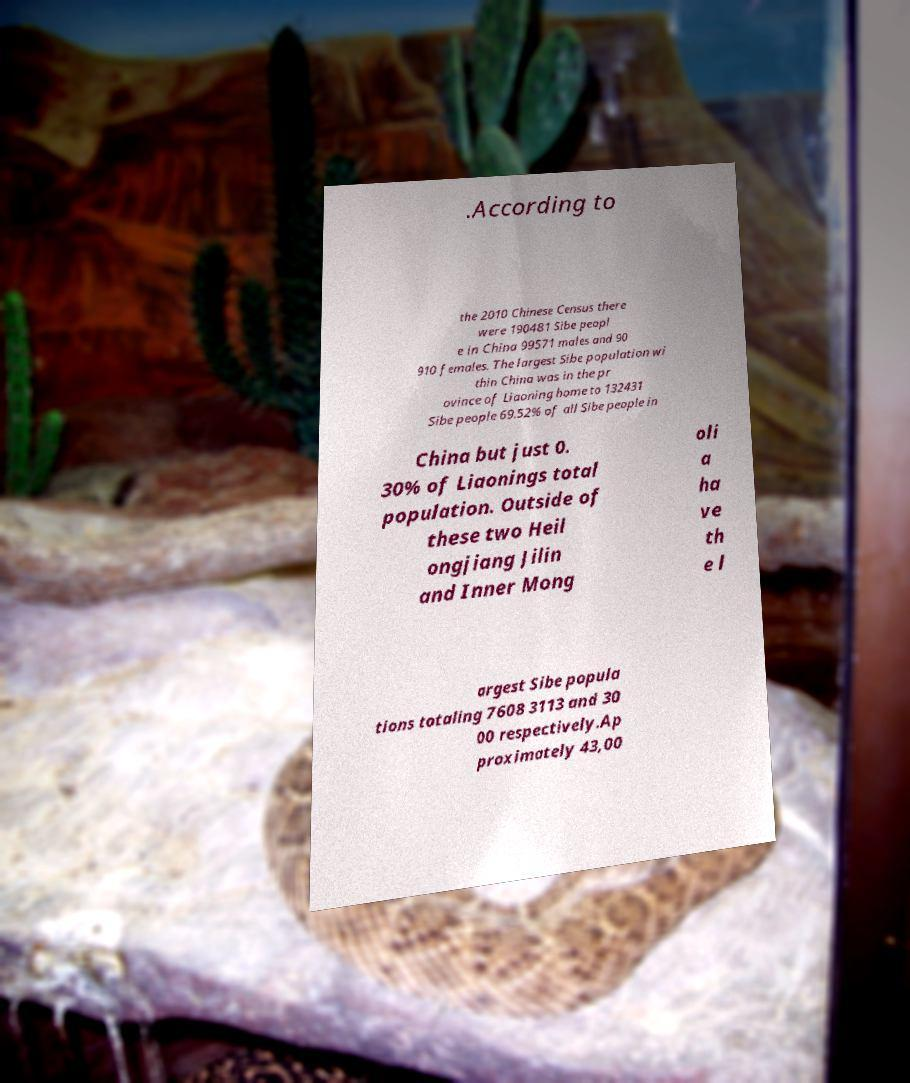I need the written content from this picture converted into text. Can you do that? .According to the 2010 Chinese Census there were 190481 Sibe peopl e in China 99571 males and 90 910 females. The largest Sibe population wi thin China was in the pr ovince of Liaoning home to 132431 Sibe people 69.52% of all Sibe people in China but just 0. 30% of Liaonings total population. Outside of these two Heil ongjiang Jilin and Inner Mong oli a ha ve th e l argest Sibe popula tions totaling 7608 3113 and 30 00 respectively.Ap proximately 43,00 